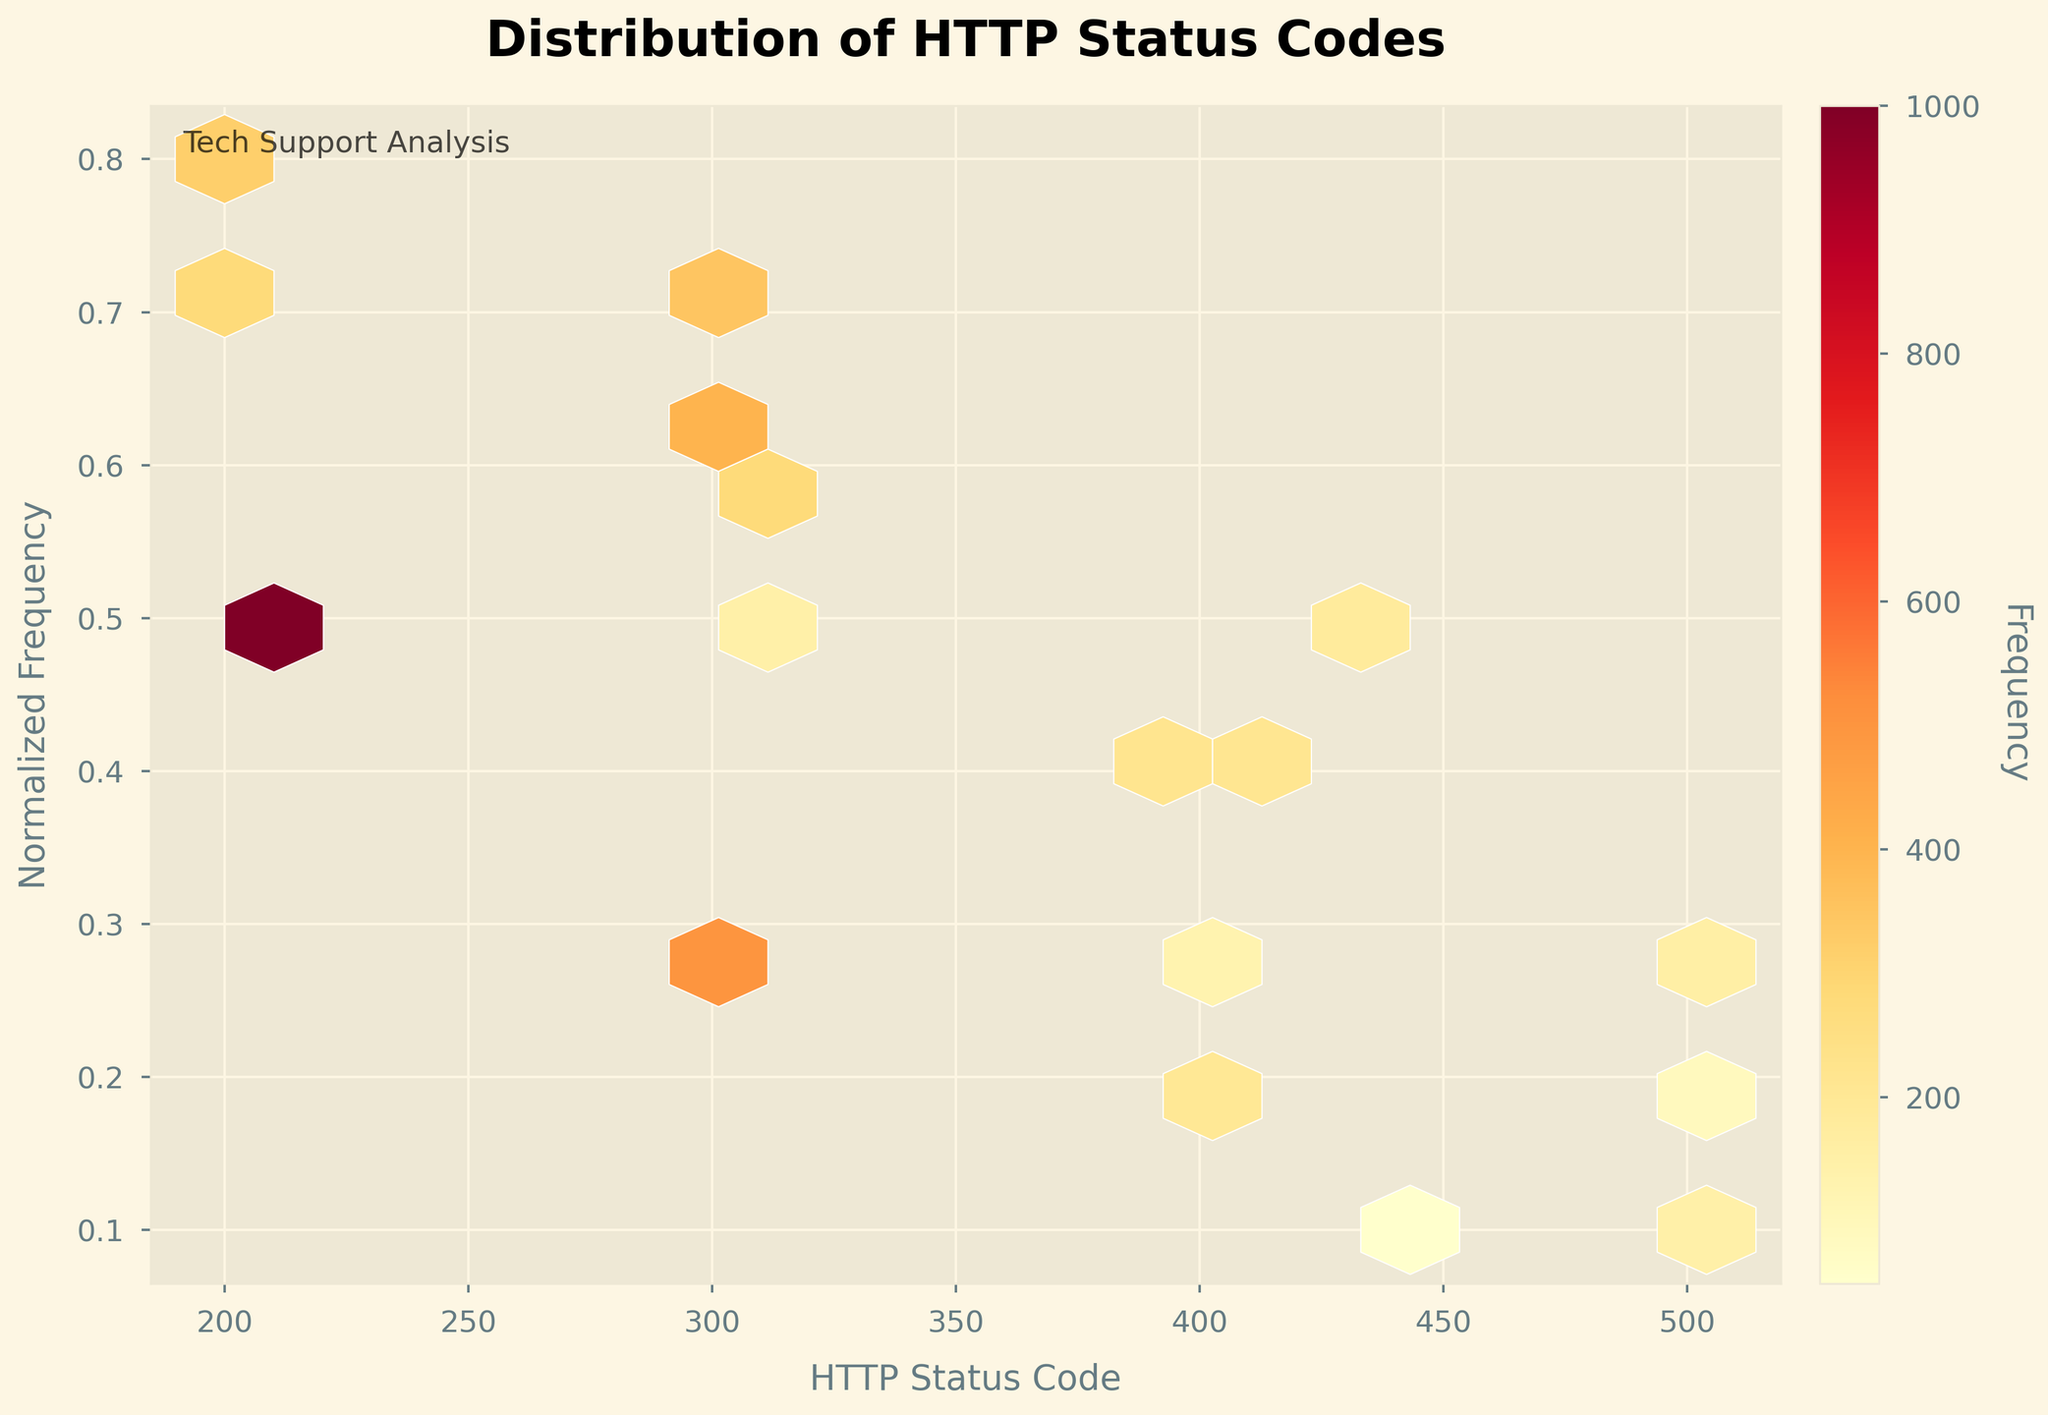What is the title of the hexbin plot? The title is typically displayed at the top of the plot. It provides an overview of what the plot is about, which helps in understanding the context of the data visualized.
Answer: Distribution of HTTP Status Codes What does the color bar in the plot represent? The color bar is used to show the scale of the frequency of HTTP status codes. It maps the colors in the hexagons to specific frequency values, indicating how often each status code appears.
Answer: Frequency Which HTTP status code has the highest frequency? By examining the color intensity of the hexagons, you can identify that the hexagon corresponding to the status code '200' is the most intense, indicating the highest frequency.
Answer: 200 How many HTTP status codes are displayed in the plot? Count the individual hexagons or status codes indicated on the x-axis of the plot. Each represents a unique HTTP status code. In this case, there are 20 unique status codes.
Answer: 20 What range of normalized frequencies does the plot cover? The y-axis represents the normalized frequency of the HTTP status codes. By looking at the y-axis labels, you can determine that the normalized frequencies range from 0.1 to 0.8.
Answer: 0.1 to 0.8 How does the frequency of status code 301 compare to that of 404? By comparing the color intensity of the hexagons for the status codes '301' and '404', it is evident that the hexagon for '301' is more intense, indicating a higher frequency.
Answer: 301 is higher than 404 Which status code has a normalized frequency closest to 0.5? Examine the y-coordinates of the hexagons and find the one closest to the 0.5 mark. The status code corresponding to this y-coordinate is '200'.
Answer: 200 Between status codes 302 and 307, which one has a higher normalized frequency? Compare the y-coordinates for the hexagons corresponding to status codes '302' and '307'. The one with a higher y-coordinate is '302', indicating a greater normalized frequency.
Answer: 302 What does each hexagon represent in this plot? Each hexagon in a hexbin plot corresponds to a bin that aggregates data points within a given range of HTTP status codes and their normalized frequencies. The color intensity of the hexagon indicates the frequency of the data points.
Answer: A bin representing aggregated data points Identify a status code with a normalized frequency of exactly 0.7. Locate the hexagon aligned with the y-coordinate of 0.7 on the plot. The hexagons that meet this criterion correspond to the status codes '304' and '206'.
Answer: 304, 206 